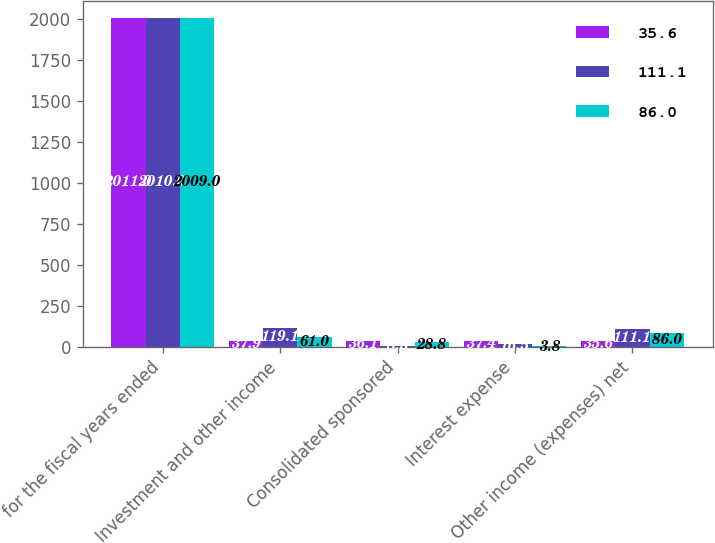Convert chart to OTSL. <chart><loc_0><loc_0><loc_500><loc_500><stacked_bar_chart><ecel><fcel>for the fiscal years ended<fcel>Investment and other income<fcel>Consolidated sponsored<fcel>Interest expense<fcel>Other income (expenses) net<nl><fcel>35.6<fcel>2011<fcel>37.9<fcel>36.1<fcel>37.4<fcel>35.6<nl><fcel>111.1<fcel>2010<fcel>119.1<fcel>8.5<fcel>16.5<fcel>111.1<nl><fcel>86<fcel>2009<fcel>61<fcel>28.8<fcel>3.8<fcel>86<nl></chart> 